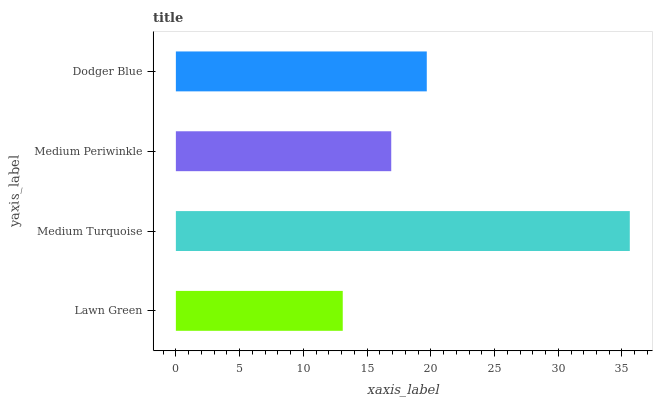Is Lawn Green the minimum?
Answer yes or no. Yes. Is Medium Turquoise the maximum?
Answer yes or no. Yes. Is Medium Periwinkle the minimum?
Answer yes or no. No. Is Medium Periwinkle the maximum?
Answer yes or no. No. Is Medium Turquoise greater than Medium Periwinkle?
Answer yes or no. Yes. Is Medium Periwinkle less than Medium Turquoise?
Answer yes or no. Yes. Is Medium Periwinkle greater than Medium Turquoise?
Answer yes or no. No. Is Medium Turquoise less than Medium Periwinkle?
Answer yes or no. No. Is Dodger Blue the high median?
Answer yes or no. Yes. Is Medium Periwinkle the low median?
Answer yes or no. Yes. Is Lawn Green the high median?
Answer yes or no. No. Is Medium Turquoise the low median?
Answer yes or no. No. 